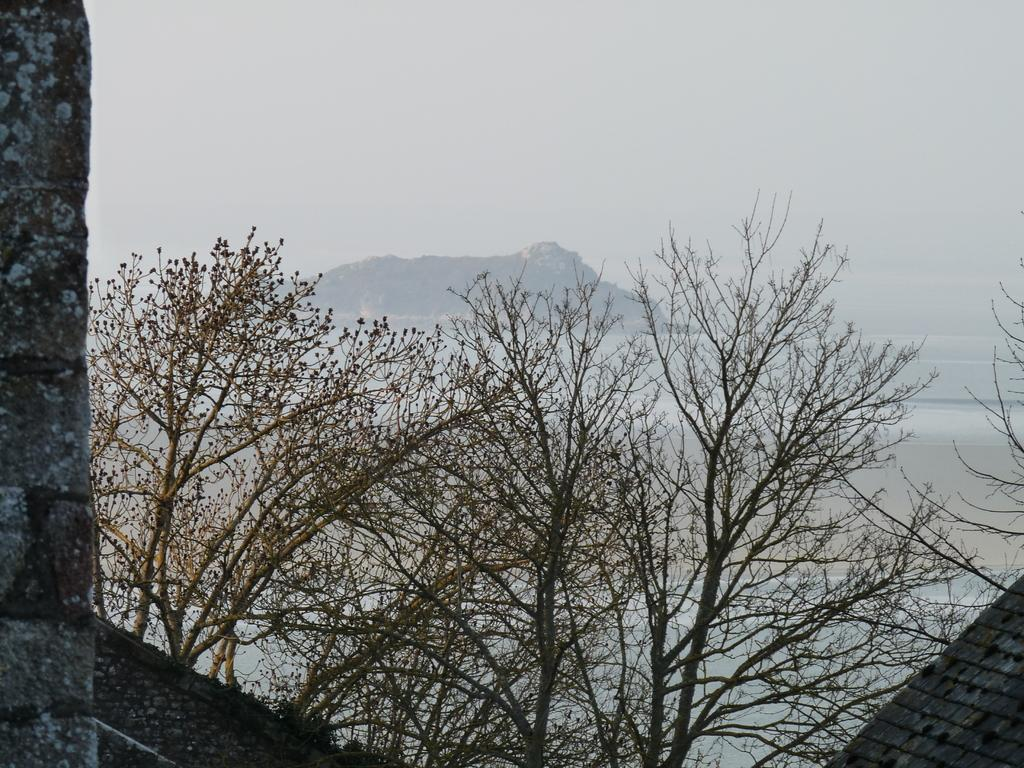What type of natural elements can be seen in the image? There are trees and a mountain in the image. What part of the natural environment is visible in the image? The sky is visible in the image. What color are the objects in the image? There are black-colored objects in the image. Can you tell me how many goldfish are swimming in the scene? There are no goldfish present in the image; it features trees, a mountain, and the sky. What is the son doing in the image? There is no son or any person present in the image. 